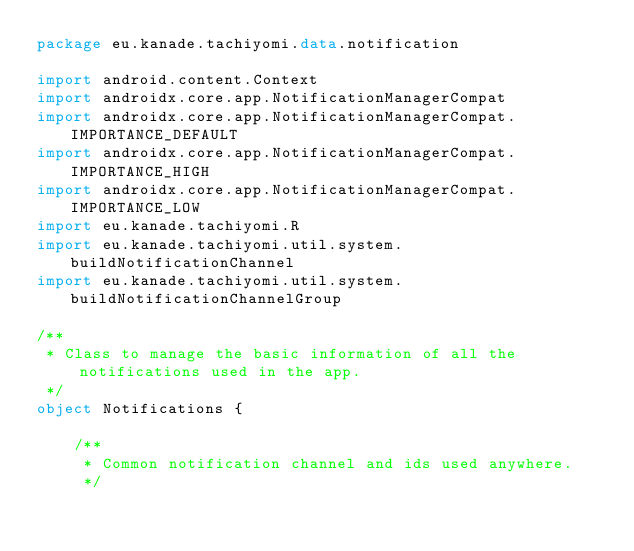Convert code to text. <code><loc_0><loc_0><loc_500><loc_500><_Kotlin_>package eu.kanade.tachiyomi.data.notification

import android.content.Context
import androidx.core.app.NotificationManagerCompat
import androidx.core.app.NotificationManagerCompat.IMPORTANCE_DEFAULT
import androidx.core.app.NotificationManagerCompat.IMPORTANCE_HIGH
import androidx.core.app.NotificationManagerCompat.IMPORTANCE_LOW
import eu.kanade.tachiyomi.R
import eu.kanade.tachiyomi.util.system.buildNotificationChannel
import eu.kanade.tachiyomi.util.system.buildNotificationChannelGroup

/**
 * Class to manage the basic information of all the notifications used in the app.
 */
object Notifications {

    /**
     * Common notification channel and ids used anywhere.
     */</code> 